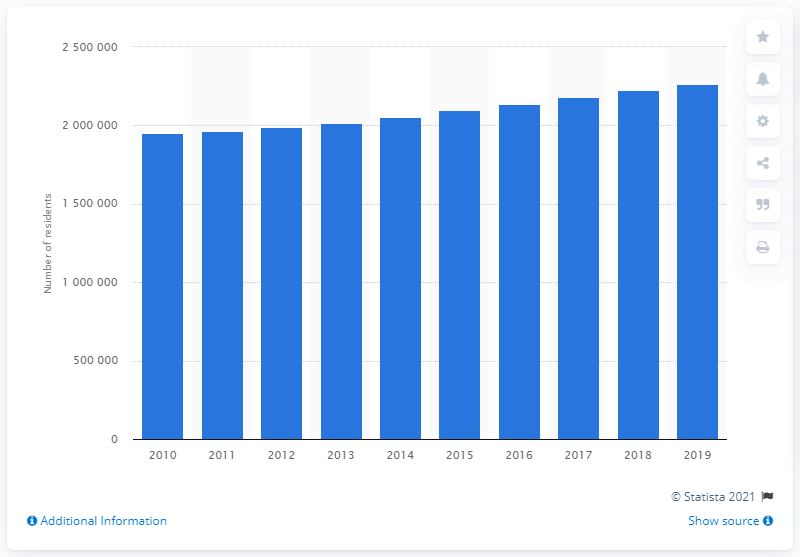How many people lived in the Las Vegas-Henderson-Paradise metropolitan area in 2019? In 2019, the Las Vegas-Henderson-Paradise metropolitan area was home to approximately 2,266,715 residents. This vibrant and dynamic region has seen a consistent increase in population over the years, reflecting its attraction as a major cultural, entertainment, and employment center. 